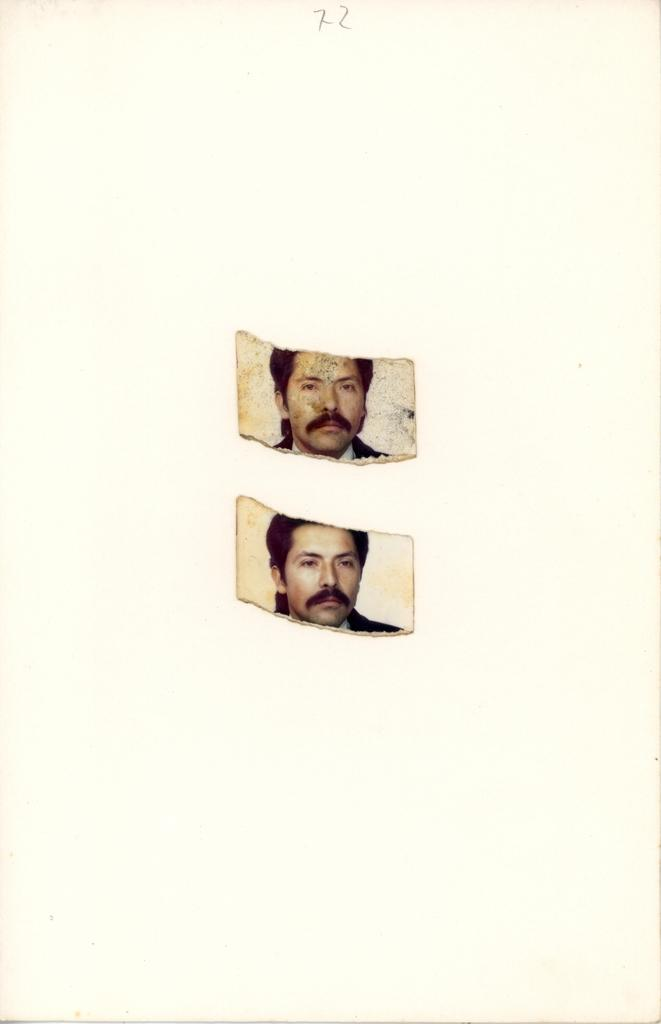What is the main subject of the two photos in the image? The main subject of the two photos is a person. What can be observed about the background of the photos? The background of the photos is white. How many trees are visible in the image? There are no trees visible in the image; the focus is on the two photos of a person. 